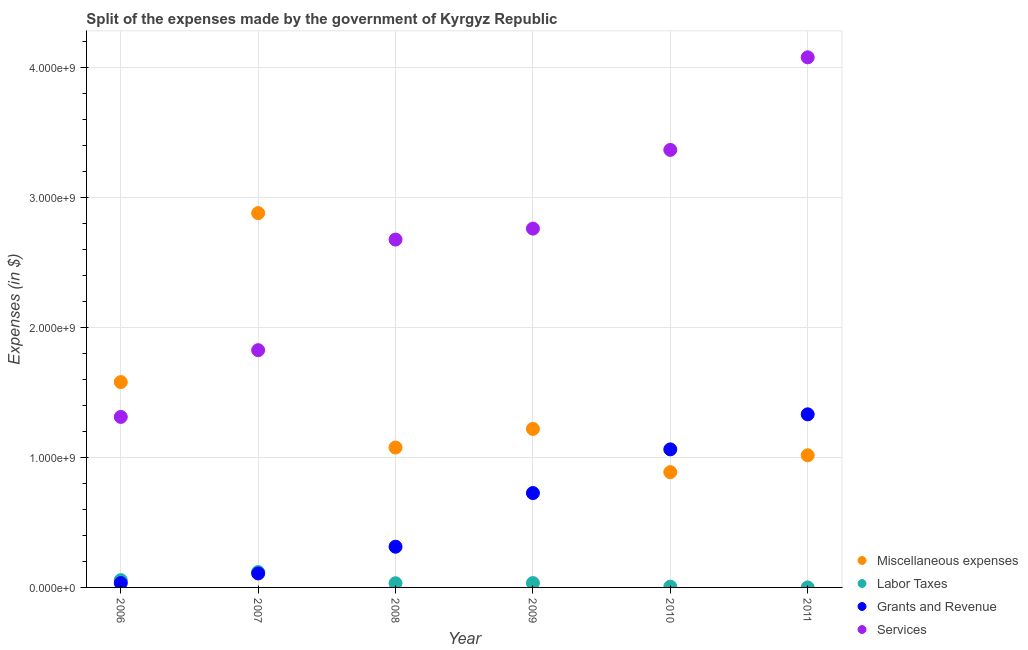How many different coloured dotlines are there?
Provide a short and direct response. 4. What is the amount spent on grants and revenue in 2011?
Your answer should be very brief. 1.33e+09. Across all years, what is the maximum amount spent on miscellaneous expenses?
Keep it short and to the point. 2.88e+09. Across all years, what is the minimum amount spent on miscellaneous expenses?
Keep it short and to the point. 8.87e+08. In which year was the amount spent on labor taxes maximum?
Ensure brevity in your answer.  2007. What is the total amount spent on grants and revenue in the graph?
Your response must be concise. 3.58e+09. What is the difference between the amount spent on labor taxes in 2008 and that in 2009?
Keep it short and to the point. -1.34e+06. What is the difference between the amount spent on labor taxes in 2010 and the amount spent on grants and revenue in 2008?
Offer a terse response. -3.07e+08. What is the average amount spent on labor taxes per year?
Offer a terse response. 4.11e+07. In the year 2007, what is the difference between the amount spent on grants and revenue and amount spent on labor taxes?
Offer a terse response. -1.07e+07. In how many years, is the amount spent on services greater than 400000000 $?
Give a very brief answer. 6. What is the ratio of the amount spent on miscellaneous expenses in 2006 to that in 2009?
Offer a terse response. 1.3. Is the amount spent on grants and revenue in 2008 less than that in 2010?
Keep it short and to the point. Yes. Is the difference between the amount spent on miscellaneous expenses in 2006 and 2008 greater than the difference between the amount spent on labor taxes in 2006 and 2008?
Keep it short and to the point. Yes. What is the difference between the highest and the second highest amount spent on miscellaneous expenses?
Your response must be concise. 1.30e+09. What is the difference between the highest and the lowest amount spent on labor taxes?
Your response must be concise. 1.18e+08. Is it the case that in every year, the sum of the amount spent on grants and revenue and amount spent on labor taxes is greater than the sum of amount spent on miscellaneous expenses and amount spent on services?
Your answer should be very brief. Yes. Is it the case that in every year, the sum of the amount spent on miscellaneous expenses and amount spent on labor taxes is greater than the amount spent on grants and revenue?
Give a very brief answer. No. Is the amount spent on grants and revenue strictly greater than the amount spent on miscellaneous expenses over the years?
Your answer should be compact. No. What is the difference between two consecutive major ticks on the Y-axis?
Ensure brevity in your answer.  1.00e+09. Are the values on the major ticks of Y-axis written in scientific E-notation?
Offer a very short reply. Yes. Does the graph contain any zero values?
Ensure brevity in your answer.  Yes. Where does the legend appear in the graph?
Offer a terse response. Bottom right. How are the legend labels stacked?
Make the answer very short. Vertical. What is the title of the graph?
Provide a short and direct response. Split of the expenses made by the government of Kyrgyz Republic. What is the label or title of the X-axis?
Provide a succinct answer. Year. What is the label or title of the Y-axis?
Give a very brief answer. Expenses (in $). What is the Expenses (in $) of Miscellaneous expenses in 2006?
Your answer should be compact. 1.58e+09. What is the Expenses (in $) of Labor Taxes in 2006?
Offer a terse response. 5.62e+07. What is the Expenses (in $) of Grants and Revenue in 2006?
Your answer should be compact. 3.35e+07. What is the Expenses (in $) in Services in 2006?
Your answer should be compact. 1.31e+09. What is the Expenses (in $) in Miscellaneous expenses in 2007?
Your answer should be compact. 2.88e+09. What is the Expenses (in $) of Labor Taxes in 2007?
Your answer should be compact. 1.18e+08. What is the Expenses (in $) in Grants and Revenue in 2007?
Offer a very short reply. 1.08e+08. What is the Expenses (in $) of Services in 2007?
Your answer should be very brief. 1.83e+09. What is the Expenses (in $) in Miscellaneous expenses in 2008?
Make the answer very short. 1.08e+09. What is the Expenses (in $) of Labor Taxes in 2008?
Offer a terse response. 3.22e+07. What is the Expenses (in $) of Grants and Revenue in 2008?
Ensure brevity in your answer.  3.13e+08. What is the Expenses (in $) in Services in 2008?
Ensure brevity in your answer.  2.68e+09. What is the Expenses (in $) in Miscellaneous expenses in 2009?
Offer a very short reply. 1.22e+09. What is the Expenses (in $) in Labor Taxes in 2009?
Make the answer very short. 3.35e+07. What is the Expenses (in $) of Grants and Revenue in 2009?
Offer a very short reply. 7.27e+08. What is the Expenses (in $) of Services in 2009?
Give a very brief answer. 2.76e+09. What is the Expenses (in $) of Miscellaneous expenses in 2010?
Provide a short and direct response. 8.87e+08. What is the Expenses (in $) in Grants and Revenue in 2010?
Your answer should be compact. 1.06e+09. What is the Expenses (in $) in Services in 2010?
Your answer should be compact. 3.37e+09. What is the Expenses (in $) of Miscellaneous expenses in 2011?
Your answer should be compact. 1.02e+09. What is the Expenses (in $) in Labor Taxes in 2011?
Offer a terse response. 0. What is the Expenses (in $) in Grants and Revenue in 2011?
Offer a terse response. 1.33e+09. What is the Expenses (in $) of Services in 2011?
Your answer should be compact. 4.08e+09. Across all years, what is the maximum Expenses (in $) of Miscellaneous expenses?
Your answer should be very brief. 2.88e+09. Across all years, what is the maximum Expenses (in $) of Labor Taxes?
Offer a very short reply. 1.18e+08. Across all years, what is the maximum Expenses (in $) in Grants and Revenue?
Your answer should be very brief. 1.33e+09. Across all years, what is the maximum Expenses (in $) in Services?
Ensure brevity in your answer.  4.08e+09. Across all years, what is the minimum Expenses (in $) in Miscellaneous expenses?
Your answer should be compact. 8.87e+08. Across all years, what is the minimum Expenses (in $) of Labor Taxes?
Offer a terse response. 0. Across all years, what is the minimum Expenses (in $) in Grants and Revenue?
Ensure brevity in your answer.  3.35e+07. Across all years, what is the minimum Expenses (in $) in Services?
Offer a terse response. 1.31e+09. What is the total Expenses (in $) of Miscellaneous expenses in the graph?
Make the answer very short. 8.67e+09. What is the total Expenses (in $) of Labor Taxes in the graph?
Offer a very short reply. 2.46e+08. What is the total Expenses (in $) in Grants and Revenue in the graph?
Your response must be concise. 3.58e+09. What is the total Expenses (in $) in Services in the graph?
Provide a succinct answer. 1.60e+1. What is the difference between the Expenses (in $) in Miscellaneous expenses in 2006 and that in 2007?
Provide a succinct answer. -1.30e+09. What is the difference between the Expenses (in $) of Labor Taxes in 2006 and that in 2007?
Offer a very short reply. -6.22e+07. What is the difference between the Expenses (in $) of Grants and Revenue in 2006 and that in 2007?
Provide a short and direct response. -7.42e+07. What is the difference between the Expenses (in $) in Services in 2006 and that in 2007?
Offer a very short reply. -5.14e+08. What is the difference between the Expenses (in $) of Miscellaneous expenses in 2006 and that in 2008?
Make the answer very short. 5.04e+08. What is the difference between the Expenses (in $) in Labor Taxes in 2006 and that in 2008?
Keep it short and to the point. 2.40e+07. What is the difference between the Expenses (in $) in Grants and Revenue in 2006 and that in 2008?
Your answer should be very brief. -2.80e+08. What is the difference between the Expenses (in $) in Services in 2006 and that in 2008?
Give a very brief answer. -1.37e+09. What is the difference between the Expenses (in $) in Miscellaneous expenses in 2006 and that in 2009?
Offer a very short reply. 3.60e+08. What is the difference between the Expenses (in $) in Labor Taxes in 2006 and that in 2009?
Provide a short and direct response. 2.27e+07. What is the difference between the Expenses (in $) of Grants and Revenue in 2006 and that in 2009?
Offer a very short reply. -6.93e+08. What is the difference between the Expenses (in $) in Services in 2006 and that in 2009?
Offer a terse response. -1.45e+09. What is the difference between the Expenses (in $) of Miscellaneous expenses in 2006 and that in 2010?
Your answer should be compact. 6.93e+08. What is the difference between the Expenses (in $) in Labor Taxes in 2006 and that in 2010?
Keep it short and to the point. 5.02e+07. What is the difference between the Expenses (in $) in Grants and Revenue in 2006 and that in 2010?
Provide a succinct answer. -1.03e+09. What is the difference between the Expenses (in $) of Services in 2006 and that in 2010?
Ensure brevity in your answer.  -2.06e+09. What is the difference between the Expenses (in $) of Miscellaneous expenses in 2006 and that in 2011?
Provide a succinct answer. 5.63e+08. What is the difference between the Expenses (in $) of Grants and Revenue in 2006 and that in 2011?
Your answer should be very brief. -1.30e+09. What is the difference between the Expenses (in $) in Services in 2006 and that in 2011?
Your answer should be compact. -2.77e+09. What is the difference between the Expenses (in $) in Miscellaneous expenses in 2007 and that in 2008?
Make the answer very short. 1.80e+09. What is the difference between the Expenses (in $) in Labor Taxes in 2007 and that in 2008?
Keep it short and to the point. 8.62e+07. What is the difference between the Expenses (in $) of Grants and Revenue in 2007 and that in 2008?
Offer a terse response. -2.06e+08. What is the difference between the Expenses (in $) of Services in 2007 and that in 2008?
Ensure brevity in your answer.  -8.52e+08. What is the difference between the Expenses (in $) in Miscellaneous expenses in 2007 and that in 2009?
Your answer should be compact. 1.66e+09. What is the difference between the Expenses (in $) in Labor Taxes in 2007 and that in 2009?
Make the answer very short. 8.49e+07. What is the difference between the Expenses (in $) of Grants and Revenue in 2007 and that in 2009?
Your response must be concise. -6.19e+08. What is the difference between the Expenses (in $) of Services in 2007 and that in 2009?
Ensure brevity in your answer.  -9.36e+08. What is the difference between the Expenses (in $) in Miscellaneous expenses in 2007 and that in 2010?
Provide a succinct answer. 1.99e+09. What is the difference between the Expenses (in $) of Labor Taxes in 2007 and that in 2010?
Your answer should be very brief. 1.12e+08. What is the difference between the Expenses (in $) in Grants and Revenue in 2007 and that in 2010?
Your answer should be compact. -9.55e+08. What is the difference between the Expenses (in $) in Services in 2007 and that in 2010?
Your response must be concise. -1.54e+09. What is the difference between the Expenses (in $) in Miscellaneous expenses in 2007 and that in 2011?
Make the answer very short. 1.86e+09. What is the difference between the Expenses (in $) in Grants and Revenue in 2007 and that in 2011?
Your response must be concise. -1.22e+09. What is the difference between the Expenses (in $) of Services in 2007 and that in 2011?
Your answer should be very brief. -2.25e+09. What is the difference between the Expenses (in $) of Miscellaneous expenses in 2008 and that in 2009?
Offer a very short reply. -1.43e+08. What is the difference between the Expenses (in $) in Labor Taxes in 2008 and that in 2009?
Offer a very short reply. -1.34e+06. What is the difference between the Expenses (in $) of Grants and Revenue in 2008 and that in 2009?
Provide a short and direct response. -4.13e+08. What is the difference between the Expenses (in $) in Services in 2008 and that in 2009?
Make the answer very short. -8.45e+07. What is the difference between the Expenses (in $) of Miscellaneous expenses in 2008 and that in 2010?
Ensure brevity in your answer.  1.90e+08. What is the difference between the Expenses (in $) of Labor Taxes in 2008 and that in 2010?
Provide a short and direct response. 2.62e+07. What is the difference between the Expenses (in $) in Grants and Revenue in 2008 and that in 2010?
Your answer should be very brief. -7.50e+08. What is the difference between the Expenses (in $) of Services in 2008 and that in 2010?
Offer a very short reply. -6.90e+08. What is the difference between the Expenses (in $) of Miscellaneous expenses in 2008 and that in 2011?
Your answer should be compact. 5.97e+07. What is the difference between the Expenses (in $) in Grants and Revenue in 2008 and that in 2011?
Give a very brief answer. -1.02e+09. What is the difference between the Expenses (in $) in Services in 2008 and that in 2011?
Ensure brevity in your answer.  -1.40e+09. What is the difference between the Expenses (in $) in Miscellaneous expenses in 2009 and that in 2010?
Offer a terse response. 3.33e+08. What is the difference between the Expenses (in $) in Labor Taxes in 2009 and that in 2010?
Provide a short and direct response. 2.75e+07. What is the difference between the Expenses (in $) of Grants and Revenue in 2009 and that in 2010?
Give a very brief answer. -3.36e+08. What is the difference between the Expenses (in $) in Services in 2009 and that in 2010?
Offer a very short reply. -6.06e+08. What is the difference between the Expenses (in $) in Miscellaneous expenses in 2009 and that in 2011?
Give a very brief answer. 2.03e+08. What is the difference between the Expenses (in $) in Grants and Revenue in 2009 and that in 2011?
Offer a terse response. -6.06e+08. What is the difference between the Expenses (in $) in Services in 2009 and that in 2011?
Provide a succinct answer. -1.32e+09. What is the difference between the Expenses (in $) of Miscellaneous expenses in 2010 and that in 2011?
Your answer should be compact. -1.30e+08. What is the difference between the Expenses (in $) of Grants and Revenue in 2010 and that in 2011?
Give a very brief answer. -2.70e+08. What is the difference between the Expenses (in $) in Services in 2010 and that in 2011?
Offer a very short reply. -7.13e+08. What is the difference between the Expenses (in $) of Miscellaneous expenses in 2006 and the Expenses (in $) of Labor Taxes in 2007?
Make the answer very short. 1.46e+09. What is the difference between the Expenses (in $) in Miscellaneous expenses in 2006 and the Expenses (in $) in Grants and Revenue in 2007?
Your answer should be compact. 1.47e+09. What is the difference between the Expenses (in $) of Miscellaneous expenses in 2006 and the Expenses (in $) of Services in 2007?
Offer a terse response. -2.46e+08. What is the difference between the Expenses (in $) in Labor Taxes in 2006 and the Expenses (in $) in Grants and Revenue in 2007?
Offer a terse response. -5.15e+07. What is the difference between the Expenses (in $) in Labor Taxes in 2006 and the Expenses (in $) in Services in 2007?
Offer a terse response. -1.77e+09. What is the difference between the Expenses (in $) in Grants and Revenue in 2006 and the Expenses (in $) in Services in 2007?
Offer a very short reply. -1.79e+09. What is the difference between the Expenses (in $) in Miscellaneous expenses in 2006 and the Expenses (in $) in Labor Taxes in 2008?
Offer a very short reply. 1.55e+09. What is the difference between the Expenses (in $) of Miscellaneous expenses in 2006 and the Expenses (in $) of Grants and Revenue in 2008?
Keep it short and to the point. 1.27e+09. What is the difference between the Expenses (in $) in Miscellaneous expenses in 2006 and the Expenses (in $) in Services in 2008?
Offer a terse response. -1.10e+09. What is the difference between the Expenses (in $) in Labor Taxes in 2006 and the Expenses (in $) in Grants and Revenue in 2008?
Your response must be concise. -2.57e+08. What is the difference between the Expenses (in $) of Labor Taxes in 2006 and the Expenses (in $) of Services in 2008?
Your answer should be compact. -2.62e+09. What is the difference between the Expenses (in $) in Grants and Revenue in 2006 and the Expenses (in $) in Services in 2008?
Offer a very short reply. -2.64e+09. What is the difference between the Expenses (in $) in Miscellaneous expenses in 2006 and the Expenses (in $) in Labor Taxes in 2009?
Offer a very short reply. 1.55e+09. What is the difference between the Expenses (in $) of Miscellaneous expenses in 2006 and the Expenses (in $) of Grants and Revenue in 2009?
Offer a terse response. 8.54e+08. What is the difference between the Expenses (in $) of Miscellaneous expenses in 2006 and the Expenses (in $) of Services in 2009?
Provide a short and direct response. -1.18e+09. What is the difference between the Expenses (in $) in Labor Taxes in 2006 and the Expenses (in $) in Grants and Revenue in 2009?
Keep it short and to the point. -6.70e+08. What is the difference between the Expenses (in $) in Labor Taxes in 2006 and the Expenses (in $) in Services in 2009?
Your answer should be compact. -2.71e+09. What is the difference between the Expenses (in $) in Grants and Revenue in 2006 and the Expenses (in $) in Services in 2009?
Keep it short and to the point. -2.73e+09. What is the difference between the Expenses (in $) in Miscellaneous expenses in 2006 and the Expenses (in $) in Labor Taxes in 2010?
Keep it short and to the point. 1.57e+09. What is the difference between the Expenses (in $) of Miscellaneous expenses in 2006 and the Expenses (in $) of Grants and Revenue in 2010?
Provide a succinct answer. 5.18e+08. What is the difference between the Expenses (in $) of Miscellaneous expenses in 2006 and the Expenses (in $) of Services in 2010?
Provide a succinct answer. -1.79e+09. What is the difference between the Expenses (in $) of Labor Taxes in 2006 and the Expenses (in $) of Grants and Revenue in 2010?
Your response must be concise. -1.01e+09. What is the difference between the Expenses (in $) of Labor Taxes in 2006 and the Expenses (in $) of Services in 2010?
Offer a terse response. -3.31e+09. What is the difference between the Expenses (in $) of Grants and Revenue in 2006 and the Expenses (in $) of Services in 2010?
Provide a short and direct response. -3.34e+09. What is the difference between the Expenses (in $) in Miscellaneous expenses in 2006 and the Expenses (in $) in Grants and Revenue in 2011?
Make the answer very short. 2.48e+08. What is the difference between the Expenses (in $) of Miscellaneous expenses in 2006 and the Expenses (in $) of Services in 2011?
Offer a very short reply. -2.50e+09. What is the difference between the Expenses (in $) in Labor Taxes in 2006 and the Expenses (in $) in Grants and Revenue in 2011?
Your answer should be compact. -1.28e+09. What is the difference between the Expenses (in $) of Labor Taxes in 2006 and the Expenses (in $) of Services in 2011?
Offer a very short reply. -4.03e+09. What is the difference between the Expenses (in $) of Grants and Revenue in 2006 and the Expenses (in $) of Services in 2011?
Make the answer very short. -4.05e+09. What is the difference between the Expenses (in $) of Miscellaneous expenses in 2007 and the Expenses (in $) of Labor Taxes in 2008?
Your answer should be very brief. 2.85e+09. What is the difference between the Expenses (in $) of Miscellaneous expenses in 2007 and the Expenses (in $) of Grants and Revenue in 2008?
Give a very brief answer. 2.57e+09. What is the difference between the Expenses (in $) in Miscellaneous expenses in 2007 and the Expenses (in $) in Services in 2008?
Ensure brevity in your answer.  2.04e+08. What is the difference between the Expenses (in $) of Labor Taxes in 2007 and the Expenses (in $) of Grants and Revenue in 2008?
Make the answer very short. -1.95e+08. What is the difference between the Expenses (in $) of Labor Taxes in 2007 and the Expenses (in $) of Services in 2008?
Provide a short and direct response. -2.56e+09. What is the difference between the Expenses (in $) in Grants and Revenue in 2007 and the Expenses (in $) in Services in 2008?
Your response must be concise. -2.57e+09. What is the difference between the Expenses (in $) of Miscellaneous expenses in 2007 and the Expenses (in $) of Labor Taxes in 2009?
Your response must be concise. 2.85e+09. What is the difference between the Expenses (in $) in Miscellaneous expenses in 2007 and the Expenses (in $) in Grants and Revenue in 2009?
Your answer should be compact. 2.16e+09. What is the difference between the Expenses (in $) in Miscellaneous expenses in 2007 and the Expenses (in $) in Services in 2009?
Your response must be concise. 1.19e+08. What is the difference between the Expenses (in $) of Labor Taxes in 2007 and the Expenses (in $) of Grants and Revenue in 2009?
Offer a very short reply. -6.08e+08. What is the difference between the Expenses (in $) in Labor Taxes in 2007 and the Expenses (in $) in Services in 2009?
Offer a very short reply. -2.64e+09. What is the difference between the Expenses (in $) in Grants and Revenue in 2007 and the Expenses (in $) in Services in 2009?
Ensure brevity in your answer.  -2.65e+09. What is the difference between the Expenses (in $) in Miscellaneous expenses in 2007 and the Expenses (in $) in Labor Taxes in 2010?
Provide a succinct answer. 2.88e+09. What is the difference between the Expenses (in $) in Miscellaneous expenses in 2007 and the Expenses (in $) in Grants and Revenue in 2010?
Offer a very short reply. 1.82e+09. What is the difference between the Expenses (in $) in Miscellaneous expenses in 2007 and the Expenses (in $) in Services in 2010?
Offer a very short reply. -4.87e+08. What is the difference between the Expenses (in $) in Labor Taxes in 2007 and the Expenses (in $) in Grants and Revenue in 2010?
Ensure brevity in your answer.  -9.45e+08. What is the difference between the Expenses (in $) of Labor Taxes in 2007 and the Expenses (in $) of Services in 2010?
Your response must be concise. -3.25e+09. What is the difference between the Expenses (in $) of Grants and Revenue in 2007 and the Expenses (in $) of Services in 2010?
Provide a short and direct response. -3.26e+09. What is the difference between the Expenses (in $) in Miscellaneous expenses in 2007 and the Expenses (in $) in Grants and Revenue in 2011?
Offer a terse response. 1.55e+09. What is the difference between the Expenses (in $) in Miscellaneous expenses in 2007 and the Expenses (in $) in Services in 2011?
Offer a terse response. -1.20e+09. What is the difference between the Expenses (in $) of Labor Taxes in 2007 and the Expenses (in $) of Grants and Revenue in 2011?
Your answer should be compact. -1.21e+09. What is the difference between the Expenses (in $) of Labor Taxes in 2007 and the Expenses (in $) of Services in 2011?
Your answer should be very brief. -3.96e+09. What is the difference between the Expenses (in $) in Grants and Revenue in 2007 and the Expenses (in $) in Services in 2011?
Your answer should be compact. -3.97e+09. What is the difference between the Expenses (in $) of Miscellaneous expenses in 2008 and the Expenses (in $) of Labor Taxes in 2009?
Give a very brief answer. 1.04e+09. What is the difference between the Expenses (in $) of Miscellaneous expenses in 2008 and the Expenses (in $) of Grants and Revenue in 2009?
Give a very brief answer. 3.50e+08. What is the difference between the Expenses (in $) in Miscellaneous expenses in 2008 and the Expenses (in $) in Services in 2009?
Make the answer very short. -1.69e+09. What is the difference between the Expenses (in $) of Labor Taxes in 2008 and the Expenses (in $) of Grants and Revenue in 2009?
Provide a short and direct response. -6.94e+08. What is the difference between the Expenses (in $) in Labor Taxes in 2008 and the Expenses (in $) in Services in 2009?
Make the answer very short. -2.73e+09. What is the difference between the Expenses (in $) in Grants and Revenue in 2008 and the Expenses (in $) in Services in 2009?
Give a very brief answer. -2.45e+09. What is the difference between the Expenses (in $) of Miscellaneous expenses in 2008 and the Expenses (in $) of Labor Taxes in 2010?
Provide a succinct answer. 1.07e+09. What is the difference between the Expenses (in $) in Miscellaneous expenses in 2008 and the Expenses (in $) in Grants and Revenue in 2010?
Your answer should be very brief. 1.41e+07. What is the difference between the Expenses (in $) of Miscellaneous expenses in 2008 and the Expenses (in $) of Services in 2010?
Your answer should be compact. -2.29e+09. What is the difference between the Expenses (in $) of Labor Taxes in 2008 and the Expenses (in $) of Grants and Revenue in 2010?
Provide a succinct answer. -1.03e+09. What is the difference between the Expenses (in $) of Labor Taxes in 2008 and the Expenses (in $) of Services in 2010?
Provide a short and direct response. -3.34e+09. What is the difference between the Expenses (in $) of Grants and Revenue in 2008 and the Expenses (in $) of Services in 2010?
Provide a short and direct response. -3.06e+09. What is the difference between the Expenses (in $) in Miscellaneous expenses in 2008 and the Expenses (in $) in Grants and Revenue in 2011?
Your response must be concise. -2.56e+08. What is the difference between the Expenses (in $) of Miscellaneous expenses in 2008 and the Expenses (in $) of Services in 2011?
Ensure brevity in your answer.  -3.00e+09. What is the difference between the Expenses (in $) in Labor Taxes in 2008 and the Expenses (in $) in Grants and Revenue in 2011?
Offer a very short reply. -1.30e+09. What is the difference between the Expenses (in $) in Labor Taxes in 2008 and the Expenses (in $) in Services in 2011?
Provide a succinct answer. -4.05e+09. What is the difference between the Expenses (in $) of Grants and Revenue in 2008 and the Expenses (in $) of Services in 2011?
Ensure brevity in your answer.  -3.77e+09. What is the difference between the Expenses (in $) of Miscellaneous expenses in 2009 and the Expenses (in $) of Labor Taxes in 2010?
Provide a succinct answer. 1.21e+09. What is the difference between the Expenses (in $) of Miscellaneous expenses in 2009 and the Expenses (in $) of Grants and Revenue in 2010?
Make the answer very short. 1.57e+08. What is the difference between the Expenses (in $) of Miscellaneous expenses in 2009 and the Expenses (in $) of Services in 2010?
Offer a terse response. -2.15e+09. What is the difference between the Expenses (in $) in Labor Taxes in 2009 and the Expenses (in $) in Grants and Revenue in 2010?
Give a very brief answer. -1.03e+09. What is the difference between the Expenses (in $) in Labor Taxes in 2009 and the Expenses (in $) in Services in 2010?
Your answer should be compact. -3.34e+09. What is the difference between the Expenses (in $) of Grants and Revenue in 2009 and the Expenses (in $) of Services in 2010?
Your response must be concise. -2.64e+09. What is the difference between the Expenses (in $) in Miscellaneous expenses in 2009 and the Expenses (in $) in Grants and Revenue in 2011?
Make the answer very short. -1.12e+08. What is the difference between the Expenses (in $) in Miscellaneous expenses in 2009 and the Expenses (in $) in Services in 2011?
Offer a very short reply. -2.86e+09. What is the difference between the Expenses (in $) of Labor Taxes in 2009 and the Expenses (in $) of Grants and Revenue in 2011?
Provide a succinct answer. -1.30e+09. What is the difference between the Expenses (in $) of Labor Taxes in 2009 and the Expenses (in $) of Services in 2011?
Make the answer very short. -4.05e+09. What is the difference between the Expenses (in $) of Grants and Revenue in 2009 and the Expenses (in $) of Services in 2011?
Ensure brevity in your answer.  -3.35e+09. What is the difference between the Expenses (in $) of Miscellaneous expenses in 2010 and the Expenses (in $) of Grants and Revenue in 2011?
Your answer should be very brief. -4.45e+08. What is the difference between the Expenses (in $) of Miscellaneous expenses in 2010 and the Expenses (in $) of Services in 2011?
Your response must be concise. -3.19e+09. What is the difference between the Expenses (in $) of Labor Taxes in 2010 and the Expenses (in $) of Grants and Revenue in 2011?
Ensure brevity in your answer.  -1.33e+09. What is the difference between the Expenses (in $) of Labor Taxes in 2010 and the Expenses (in $) of Services in 2011?
Offer a very short reply. -4.08e+09. What is the difference between the Expenses (in $) in Grants and Revenue in 2010 and the Expenses (in $) in Services in 2011?
Offer a terse response. -3.02e+09. What is the average Expenses (in $) in Miscellaneous expenses per year?
Keep it short and to the point. 1.44e+09. What is the average Expenses (in $) of Labor Taxes per year?
Provide a succinct answer. 4.11e+07. What is the average Expenses (in $) in Grants and Revenue per year?
Your answer should be compact. 5.96e+08. What is the average Expenses (in $) of Services per year?
Keep it short and to the point. 2.67e+09. In the year 2006, what is the difference between the Expenses (in $) in Miscellaneous expenses and Expenses (in $) in Labor Taxes?
Make the answer very short. 1.52e+09. In the year 2006, what is the difference between the Expenses (in $) of Miscellaneous expenses and Expenses (in $) of Grants and Revenue?
Make the answer very short. 1.55e+09. In the year 2006, what is the difference between the Expenses (in $) in Miscellaneous expenses and Expenses (in $) in Services?
Provide a short and direct response. 2.68e+08. In the year 2006, what is the difference between the Expenses (in $) in Labor Taxes and Expenses (in $) in Grants and Revenue?
Offer a terse response. 2.27e+07. In the year 2006, what is the difference between the Expenses (in $) of Labor Taxes and Expenses (in $) of Services?
Keep it short and to the point. -1.26e+09. In the year 2006, what is the difference between the Expenses (in $) of Grants and Revenue and Expenses (in $) of Services?
Your answer should be very brief. -1.28e+09. In the year 2007, what is the difference between the Expenses (in $) in Miscellaneous expenses and Expenses (in $) in Labor Taxes?
Keep it short and to the point. 2.76e+09. In the year 2007, what is the difference between the Expenses (in $) in Miscellaneous expenses and Expenses (in $) in Grants and Revenue?
Offer a very short reply. 2.77e+09. In the year 2007, what is the difference between the Expenses (in $) in Miscellaneous expenses and Expenses (in $) in Services?
Your response must be concise. 1.06e+09. In the year 2007, what is the difference between the Expenses (in $) in Labor Taxes and Expenses (in $) in Grants and Revenue?
Offer a terse response. 1.07e+07. In the year 2007, what is the difference between the Expenses (in $) in Labor Taxes and Expenses (in $) in Services?
Offer a very short reply. -1.71e+09. In the year 2007, what is the difference between the Expenses (in $) of Grants and Revenue and Expenses (in $) of Services?
Provide a short and direct response. -1.72e+09. In the year 2008, what is the difference between the Expenses (in $) in Miscellaneous expenses and Expenses (in $) in Labor Taxes?
Provide a succinct answer. 1.04e+09. In the year 2008, what is the difference between the Expenses (in $) of Miscellaneous expenses and Expenses (in $) of Grants and Revenue?
Offer a terse response. 7.64e+08. In the year 2008, what is the difference between the Expenses (in $) in Miscellaneous expenses and Expenses (in $) in Services?
Give a very brief answer. -1.60e+09. In the year 2008, what is the difference between the Expenses (in $) of Labor Taxes and Expenses (in $) of Grants and Revenue?
Offer a terse response. -2.81e+08. In the year 2008, what is the difference between the Expenses (in $) of Labor Taxes and Expenses (in $) of Services?
Give a very brief answer. -2.65e+09. In the year 2008, what is the difference between the Expenses (in $) in Grants and Revenue and Expenses (in $) in Services?
Your response must be concise. -2.36e+09. In the year 2009, what is the difference between the Expenses (in $) in Miscellaneous expenses and Expenses (in $) in Labor Taxes?
Your response must be concise. 1.19e+09. In the year 2009, what is the difference between the Expenses (in $) of Miscellaneous expenses and Expenses (in $) of Grants and Revenue?
Give a very brief answer. 4.94e+08. In the year 2009, what is the difference between the Expenses (in $) in Miscellaneous expenses and Expenses (in $) in Services?
Provide a succinct answer. -1.54e+09. In the year 2009, what is the difference between the Expenses (in $) of Labor Taxes and Expenses (in $) of Grants and Revenue?
Provide a short and direct response. -6.93e+08. In the year 2009, what is the difference between the Expenses (in $) of Labor Taxes and Expenses (in $) of Services?
Offer a very short reply. -2.73e+09. In the year 2009, what is the difference between the Expenses (in $) in Grants and Revenue and Expenses (in $) in Services?
Your answer should be very brief. -2.04e+09. In the year 2010, what is the difference between the Expenses (in $) in Miscellaneous expenses and Expenses (in $) in Labor Taxes?
Give a very brief answer. 8.81e+08. In the year 2010, what is the difference between the Expenses (in $) of Miscellaneous expenses and Expenses (in $) of Grants and Revenue?
Make the answer very short. -1.75e+08. In the year 2010, what is the difference between the Expenses (in $) of Miscellaneous expenses and Expenses (in $) of Services?
Give a very brief answer. -2.48e+09. In the year 2010, what is the difference between the Expenses (in $) in Labor Taxes and Expenses (in $) in Grants and Revenue?
Keep it short and to the point. -1.06e+09. In the year 2010, what is the difference between the Expenses (in $) in Labor Taxes and Expenses (in $) in Services?
Your answer should be very brief. -3.36e+09. In the year 2010, what is the difference between the Expenses (in $) of Grants and Revenue and Expenses (in $) of Services?
Make the answer very short. -2.31e+09. In the year 2011, what is the difference between the Expenses (in $) of Miscellaneous expenses and Expenses (in $) of Grants and Revenue?
Give a very brief answer. -3.15e+08. In the year 2011, what is the difference between the Expenses (in $) in Miscellaneous expenses and Expenses (in $) in Services?
Your answer should be very brief. -3.06e+09. In the year 2011, what is the difference between the Expenses (in $) in Grants and Revenue and Expenses (in $) in Services?
Give a very brief answer. -2.75e+09. What is the ratio of the Expenses (in $) in Miscellaneous expenses in 2006 to that in 2007?
Your answer should be very brief. 0.55. What is the ratio of the Expenses (in $) in Labor Taxes in 2006 to that in 2007?
Offer a very short reply. 0.47. What is the ratio of the Expenses (in $) in Grants and Revenue in 2006 to that in 2007?
Your response must be concise. 0.31. What is the ratio of the Expenses (in $) of Services in 2006 to that in 2007?
Give a very brief answer. 0.72. What is the ratio of the Expenses (in $) of Miscellaneous expenses in 2006 to that in 2008?
Offer a very short reply. 1.47. What is the ratio of the Expenses (in $) of Labor Taxes in 2006 to that in 2008?
Offer a very short reply. 1.75. What is the ratio of the Expenses (in $) in Grants and Revenue in 2006 to that in 2008?
Your answer should be very brief. 0.11. What is the ratio of the Expenses (in $) in Services in 2006 to that in 2008?
Ensure brevity in your answer.  0.49. What is the ratio of the Expenses (in $) of Miscellaneous expenses in 2006 to that in 2009?
Your answer should be compact. 1.3. What is the ratio of the Expenses (in $) in Labor Taxes in 2006 to that in 2009?
Your response must be concise. 1.68. What is the ratio of the Expenses (in $) of Grants and Revenue in 2006 to that in 2009?
Provide a succinct answer. 0.05. What is the ratio of the Expenses (in $) in Services in 2006 to that in 2009?
Your response must be concise. 0.48. What is the ratio of the Expenses (in $) in Miscellaneous expenses in 2006 to that in 2010?
Provide a succinct answer. 1.78. What is the ratio of the Expenses (in $) of Labor Taxes in 2006 to that in 2010?
Offer a very short reply. 9.37. What is the ratio of the Expenses (in $) of Grants and Revenue in 2006 to that in 2010?
Your answer should be very brief. 0.03. What is the ratio of the Expenses (in $) in Services in 2006 to that in 2010?
Ensure brevity in your answer.  0.39. What is the ratio of the Expenses (in $) of Miscellaneous expenses in 2006 to that in 2011?
Provide a short and direct response. 1.55. What is the ratio of the Expenses (in $) in Grants and Revenue in 2006 to that in 2011?
Your answer should be compact. 0.03. What is the ratio of the Expenses (in $) in Services in 2006 to that in 2011?
Offer a very short reply. 0.32. What is the ratio of the Expenses (in $) of Miscellaneous expenses in 2007 to that in 2008?
Offer a very short reply. 2.68. What is the ratio of the Expenses (in $) in Labor Taxes in 2007 to that in 2008?
Give a very brief answer. 3.68. What is the ratio of the Expenses (in $) in Grants and Revenue in 2007 to that in 2008?
Keep it short and to the point. 0.34. What is the ratio of the Expenses (in $) in Services in 2007 to that in 2008?
Offer a terse response. 0.68. What is the ratio of the Expenses (in $) in Miscellaneous expenses in 2007 to that in 2009?
Make the answer very short. 2.36. What is the ratio of the Expenses (in $) of Labor Taxes in 2007 to that in 2009?
Provide a short and direct response. 3.53. What is the ratio of the Expenses (in $) of Grants and Revenue in 2007 to that in 2009?
Offer a terse response. 0.15. What is the ratio of the Expenses (in $) in Services in 2007 to that in 2009?
Ensure brevity in your answer.  0.66. What is the ratio of the Expenses (in $) in Miscellaneous expenses in 2007 to that in 2010?
Offer a very short reply. 3.25. What is the ratio of the Expenses (in $) in Labor Taxes in 2007 to that in 2010?
Offer a very short reply. 19.73. What is the ratio of the Expenses (in $) in Grants and Revenue in 2007 to that in 2010?
Your answer should be very brief. 0.1. What is the ratio of the Expenses (in $) of Services in 2007 to that in 2010?
Your answer should be compact. 0.54. What is the ratio of the Expenses (in $) in Miscellaneous expenses in 2007 to that in 2011?
Ensure brevity in your answer.  2.83. What is the ratio of the Expenses (in $) in Grants and Revenue in 2007 to that in 2011?
Ensure brevity in your answer.  0.08. What is the ratio of the Expenses (in $) in Services in 2007 to that in 2011?
Your answer should be compact. 0.45. What is the ratio of the Expenses (in $) in Miscellaneous expenses in 2008 to that in 2009?
Your answer should be very brief. 0.88. What is the ratio of the Expenses (in $) in Labor Taxes in 2008 to that in 2009?
Give a very brief answer. 0.96. What is the ratio of the Expenses (in $) of Grants and Revenue in 2008 to that in 2009?
Provide a succinct answer. 0.43. What is the ratio of the Expenses (in $) of Services in 2008 to that in 2009?
Keep it short and to the point. 0.97. What is the ratio of the Expenses (in $) in Miscellaneous expenses in 2008 to that in 2010?
Provide a short and direct response. 1.21. What is the ratio of the Expenses (in $) in Labor Taxes in 2008 to that in 2010?
Your answer should be compact. 5.37. What is the ratio of the Expenses (in $) in Grants and Revenue in 2008 to that in 2010?
Offer a terse response. 0.29. What is the ratio of the Expenses (in $) in Services in 2008 to that in 2010?
Provide a short and direct response. 0.8. What is the ratio of the Expenses (in $) of Miscellaneous expenses in 2008 to that in 2011?
Provide a short and direct response. 1.06. What is the ratio of the Expenses (in $) of Grants and Revenue in 2008 to that in 2011?
Give a very brief answer. 0.24. What is the ratio of the Expenses (in $) of Services in 2008 to that in 2011?
Offer a very short reply. 0.66. What is the ratio of the Expenses (in $) of Miscellaneous expenses in 2009 to that in 2010?
Your answer should be very brief. 1.38. What is the ratio of the Expenses (in $) of Labor Taxes in 2009 to that in 2010?
Keep it short and to the point. 5.59. What is the ratio of the Expenses (in $) in Grants and Revenue in 2009 to that in 2010?
Keep it short and to the point. 0.68. What is the ratio of the Expenses (in $) of Services in 2009 to that in 2010?
Your response must be concise. 0.82. What is the ratio of the Expenses (in $) in Miscellaneous expenses in 2009 to that in 2011?
Your answer should be very brief. 1.2. What is the ratio of the Expenses (in $) in Grants and Revenue in 2009 to that in 2011?
Your answer should be very brief. 0.55. What is the ratio of the Expenses (in $) of Services in 2009 to that in 2011?
Give a very brief answer. 0.68. What is the ratio of the Expenses (in $) of Miscellaneous expenses in 2010 to that in 2011?
Offer a terse response. 0.87. What is the ratio of the Expenses (in $) of Grants and Revenue in 2010 to that in 2011?
Your answer should be compact. 0.8. What is the ratio of the Expenses (in $) in Services in 2010 to that in 2011?
Offer a very short reply. 0.83. What is the difference between the highest and the second highest Expenses (in $) of Miscellaneous expenses?
Your answer should be compact. 1.30e+09. What is the difference between the highest and the second highest Expenses (in $) of Labor Taxes?
Your answer should be compact. 6.22e+07. What is the difference between the highest and the second highest Expenses (in $) in Grants and Revenue?
Your response must be concise. 2.70e+08. What is the difference between the highest and the second highest Expenses (in $) in Services?
Make the answer very short. 7.13e+08. What is the difference between the highest and the lowest Expenses (in $) in Miscellaneous expenses?
Offer a very short reply. 1.99e+09. What is the difference between the highest and the lowest Expenses (in $) of Labor Taxes?
Make the answer very short. 1.18e+08. What is the difference between the highest and the lowest Expenses (in $) in Grants and Revenue?
Ensure brevity in your answer.  1.30e+09. What is the difference between the highest and the lowest Expenses (in $) of Services?
Ensure brevity in your answer.  2.77e+09. 